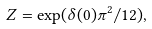<formula> <loc_0><loc_0><loc_500><loc_500>Z = \exp ( \delta ( 0 ) \pi ^ { 2 } / 1 2 ) ,</formula> 